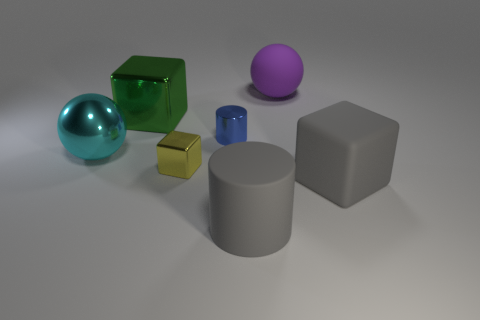Add 2 small red shiny balls. How many objects exist? 9 Subtract all balls. How many objects are left? 5 Add 3 tiny blue metallic cubes. How many tiny blue metallic cubes exist? 3 Subtract 0 cyan blocks. How many objects are left? 7 Subtract all gray cylinders. Subtract all balls. How many objects are left? 4 Add 6 blocks. How many blocks are left? 9 